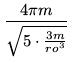Convert formula to latex. <formula><loc_0><loc_0><loc_500><loc_500>\frac { 4 \pi m } { \sqrt { 5 \cdot \frac { 3 m } { r o ^ { 3 } } } }</formula> 